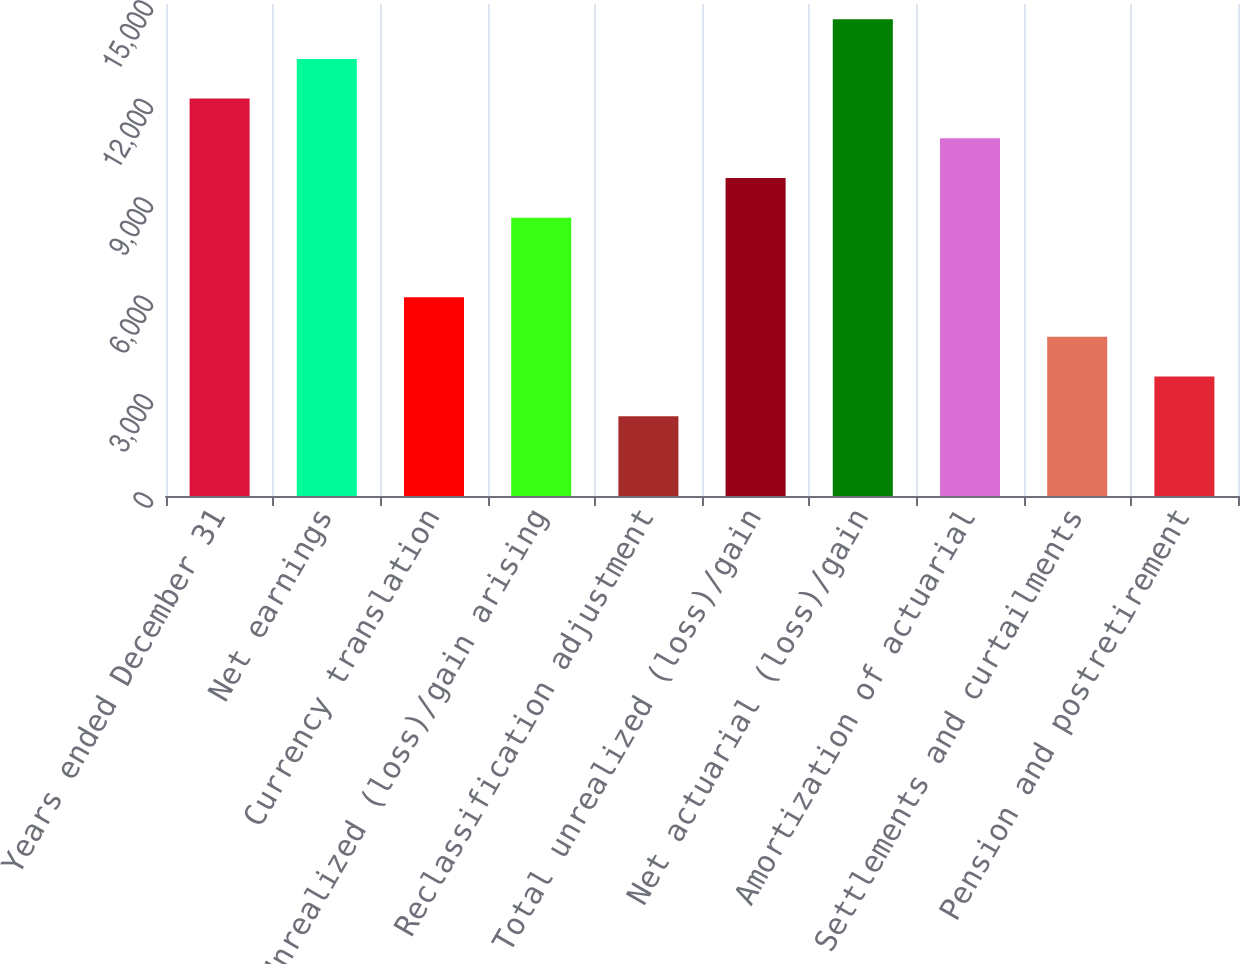Convert chart to OTSL. <chart><loc_0><loc_0><loc_500><loc_500><bar_chart><fcel>Years ended December 31<fcel>Net earnings<fcel>Currency translation<fcel>Unrealized (loss)/gain arising<fcel>Reclassification adjustment<fcel>Total unrealized (loss)/gain<fcel>Net actuarial (loss)/gain<fcel>Amortization of actuarial<fcel>Settlements and curtailments<fcel>Pension and postretirement<nl><fcel>12116<fcel>13326.7<fcel>6062.5<fcel>8483.9<fcel>2430.4<fcel>9694.6<fcel>14537.4<fcel>10905.3<fcel>4851.8<fcel>3641.1<nl></chart> 